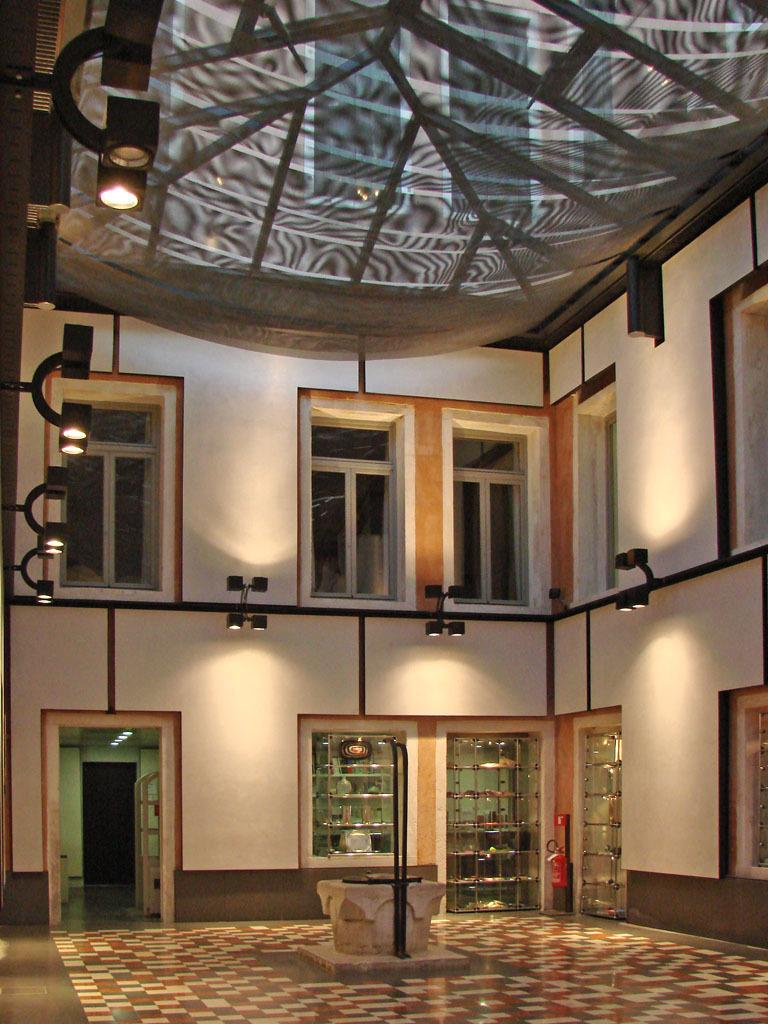Where was the image taken? The image was taken inside a building. What can be seen through the windows in the image? The image does not show what can be seen through the windows. What is the purpose of the door in the image? The purpose of the door in the image is to provide access to another room or area. What is visible at the bottom of the image? The floor is visible at the bottom of the image. What is covering the top of the image? There is cloth at the top of the image. What is providing illumination in the image? There are lights in the image. How many icicles are hanging from the door in the image? There are no icicles hanging from the door in the image. What type of lumber is being used to construct the walls in the image? The image does not show the construction materials used for the walls. 